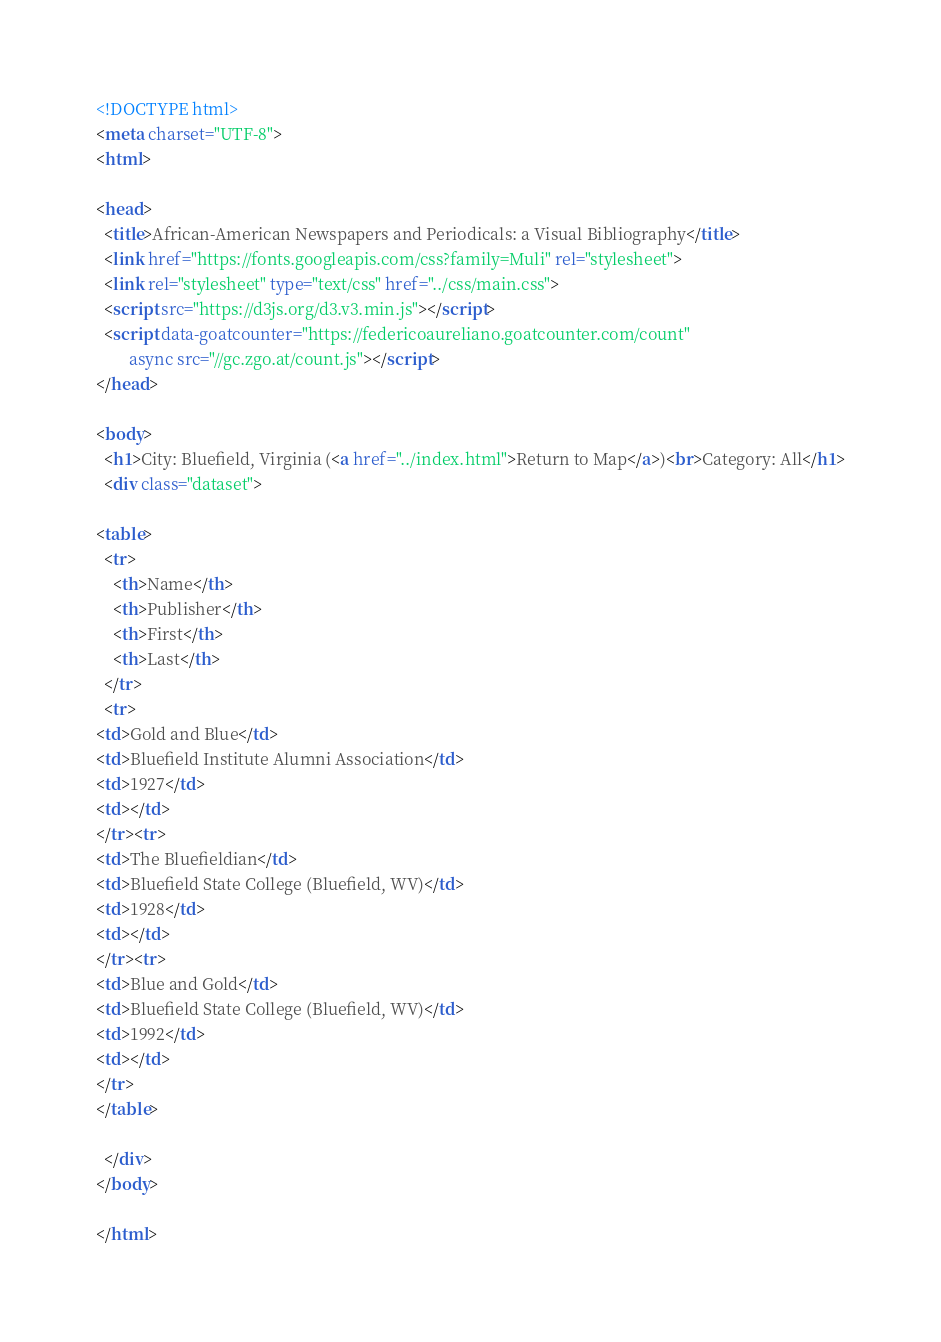<code> <loc_0><loc_0><loc_500><loc_500><_HTML_>
<!DOCTYPE html>
<meta charset="UTF-8">
<html>

<head>
  <title>African-American Newspapers and Periodicals: a Visual Bibliography</title>
  <link href="https://fonts.googleapis.com/css?family=Muli" rel="stylesheet">
  <link rel="stylesheet" type="text/css" href="../css/main.css">
  <script src="https://d3js.org/d3.v3.min.js"></script>
  <script data-goatcounter="https://federicoaureliano.goatcounter.com/count"
        async src="//gc.zgo.at/count.js"></script>
</head>

<body>
  <h1>City: Bluefield, Virginia (<a href="../index.html">Return to Map</a>)<br>Category: All</h1>
  <div class="dataset">
  
<table>
  <tr>
    <th>Name</th>
    <th>Publisher</th>
    <th>First</th>
    <th>Last</th>
  </tr>
  <tr>
<td>Gold and Blue</td>
<td>Bluefield Institute Alumni Association</td>
<td>1927</td>
<td></td>
</tr><tr>
<td>The Bluefieldian</td>
<td>Bluefield State College (Bluefield, WV)</td>
<td>1928</td>
<td></td>
</tr><tr>
<td>Blue and Gold</td>
<td>Bluefield State College (Bluefield, WV)</td>
<td>1992</td>
<td></td>
</tr>
</table>
    
  </div>
</body>

</html>
</code> 